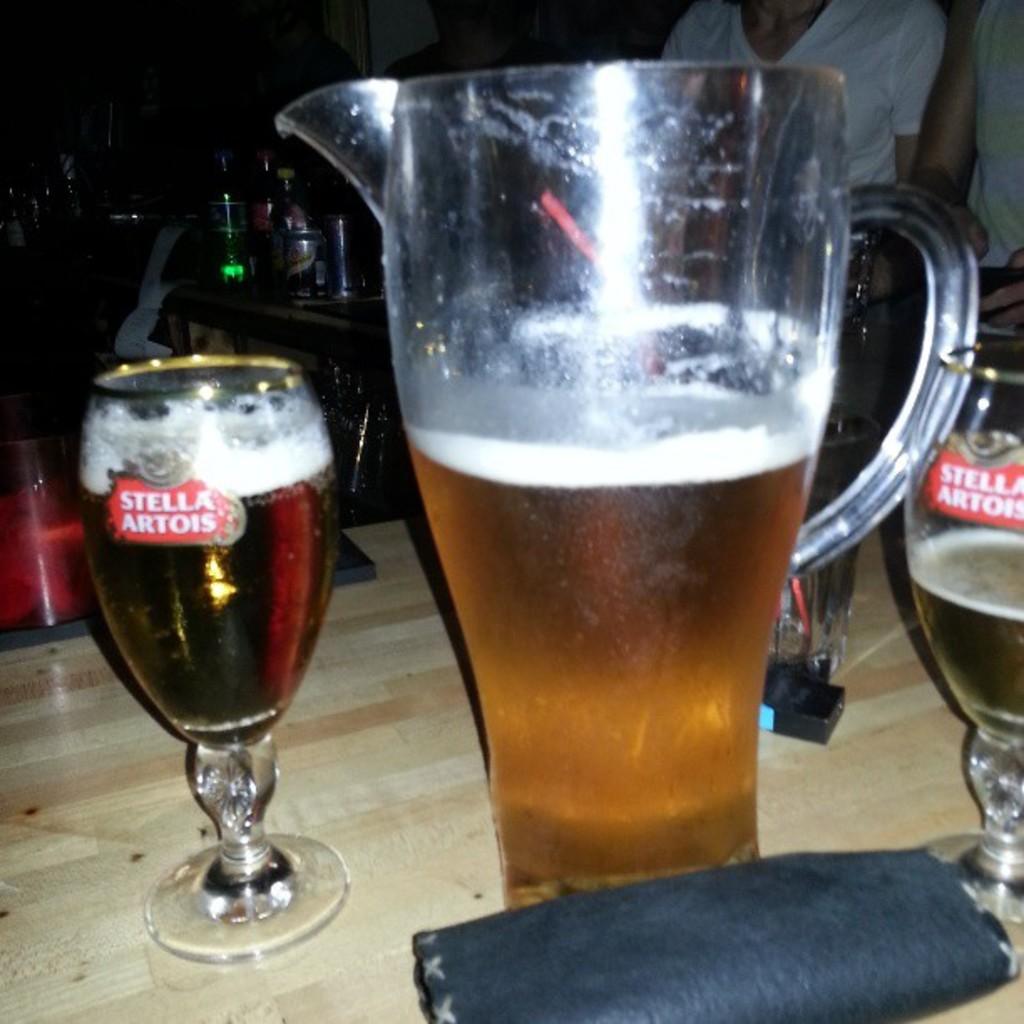What is the name on the wine glass?
Ensure brevity in your answer.  Stella artois. What is the brand of the beer?
Make the answer very short. Stella artois. 